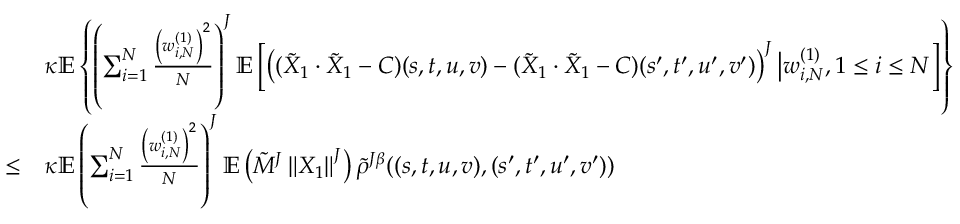<formula> <loc_0><loc_0><loc_500><loc_500>\begin{array} { r l } & { \kappa \mathbb { E } \left \{ \left ( \sum _ { i = 1 } ^ { N } \frac { \left ( w _ { i , N } ^ { ( 1 ) } \right ) ^ { 2 } } { N } \right ) ^ { J } \mathbb { E } \left [ \left ( ( \tilde { X } _ { 1 } \cdot \tilde { X } _ { 1 } - C ) ( s , t , u , v ) - ( \tilde { X } _ { 1 } \cdot \tilde { X } _ { 1 } - C ) ( s ^ { \prime } , t ^ { \prime } , u ^ { \prime } , v ^ { \prime } ) \right ) ^ { J } \Big | w _ { i , N } ^ { ( 1 ) } , 1 \leq i \leq N \right ] \right \} } \\ { \leq } & { \kappa \mathbb { E } \left ( \sum _ { i = 1 } ^ { N } \frac { \left ( w _ { i , N } ^ { ( 1 ) } \right ) ^ { 2 } } { N } \right ) ^ { J } \mathbb { E } \left ( \tilde { M } ^ { J } \left \| X _ { 1 } \right \| ^ { J } \right ) \tilde { \rho } ^ { J \beta } ( ( s , t , u , v ) , ( s ^ { \prime } , t ^ { \prime } , u ^ { \prime } , v ^ { \prime } ) ) } \end{array}</formula> 